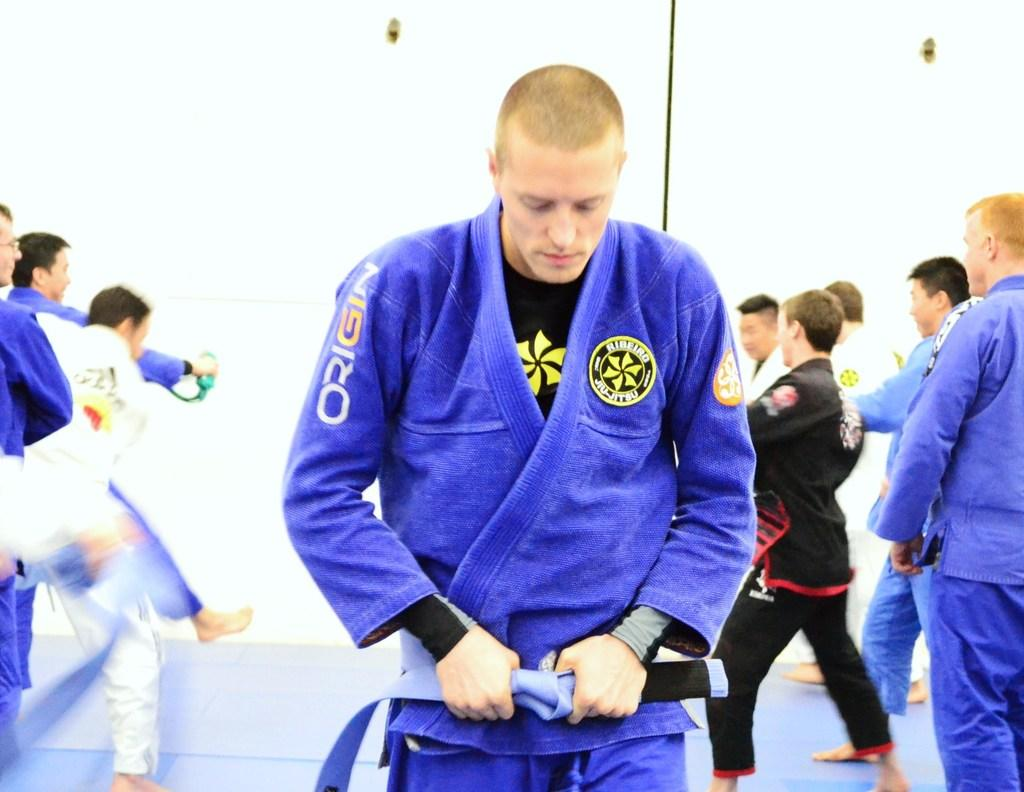Provide a one-sentence caption for the provided image. A martial arts participant wears a robe by Origin. 